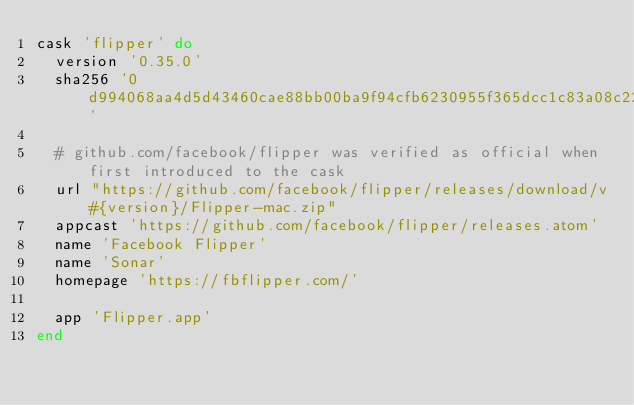Convert code to text. <code><loc_0><loc_0><loc_500><loc_500><_Ruby_>cask 'flipper' do
  version '0.35.0'
  sha256 '0d994068aa4d5d43460cae88bb00ba9f94cfb6230955f365dcc1c83a08c225ea'

  # github.com/facebook/flipper was verified as official when first introduced to the cask
  url "https://github.com/facebook/flipper/releases/download/v#{version}/Flipper-mac.zip"
  appcast 'https://github.com/facebook/flipper/releases.atom'
  name 'Facebook Flipper'
  name 'Sonar'
  homepage 'https://fbflipper.com/'

  app 'Flipper.app'
end
</code> 